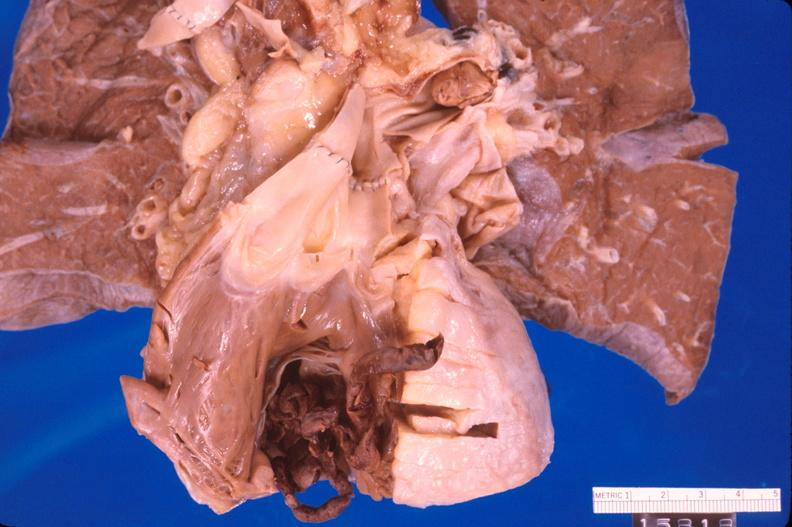s heart present?
Answer the question using a single word or phrase. Yes 